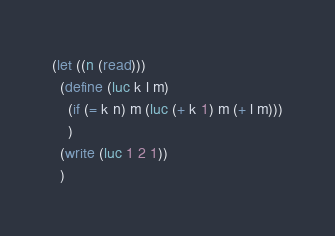<code> <loc_0><loc_0><loc_500><loc_500><_Scheme_>(let ((n (read)))
  (define (luc k l m)
    (if (= k n) m (luc (+ k 1) m (+ l m)))
    )
  (write (luc 1 2 1))
  )
</code> 